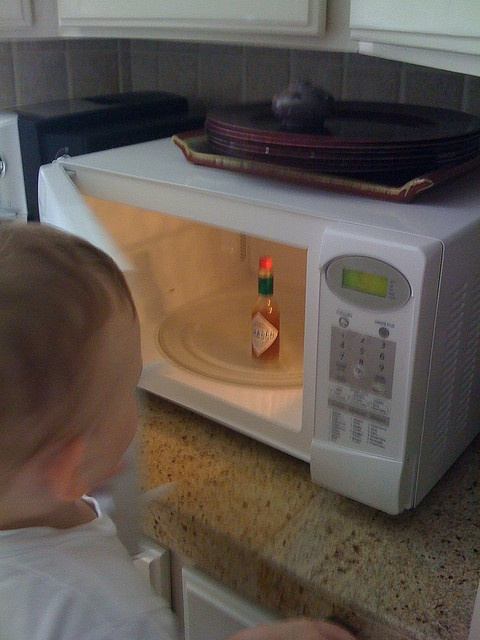Describe the objects in this image and their specific colors. I can see microwave in gray, darkgray, and brown tones, people in gray, maroon, brown, and black tones, and bottle in gray, brown, and maroon tones in this image. 